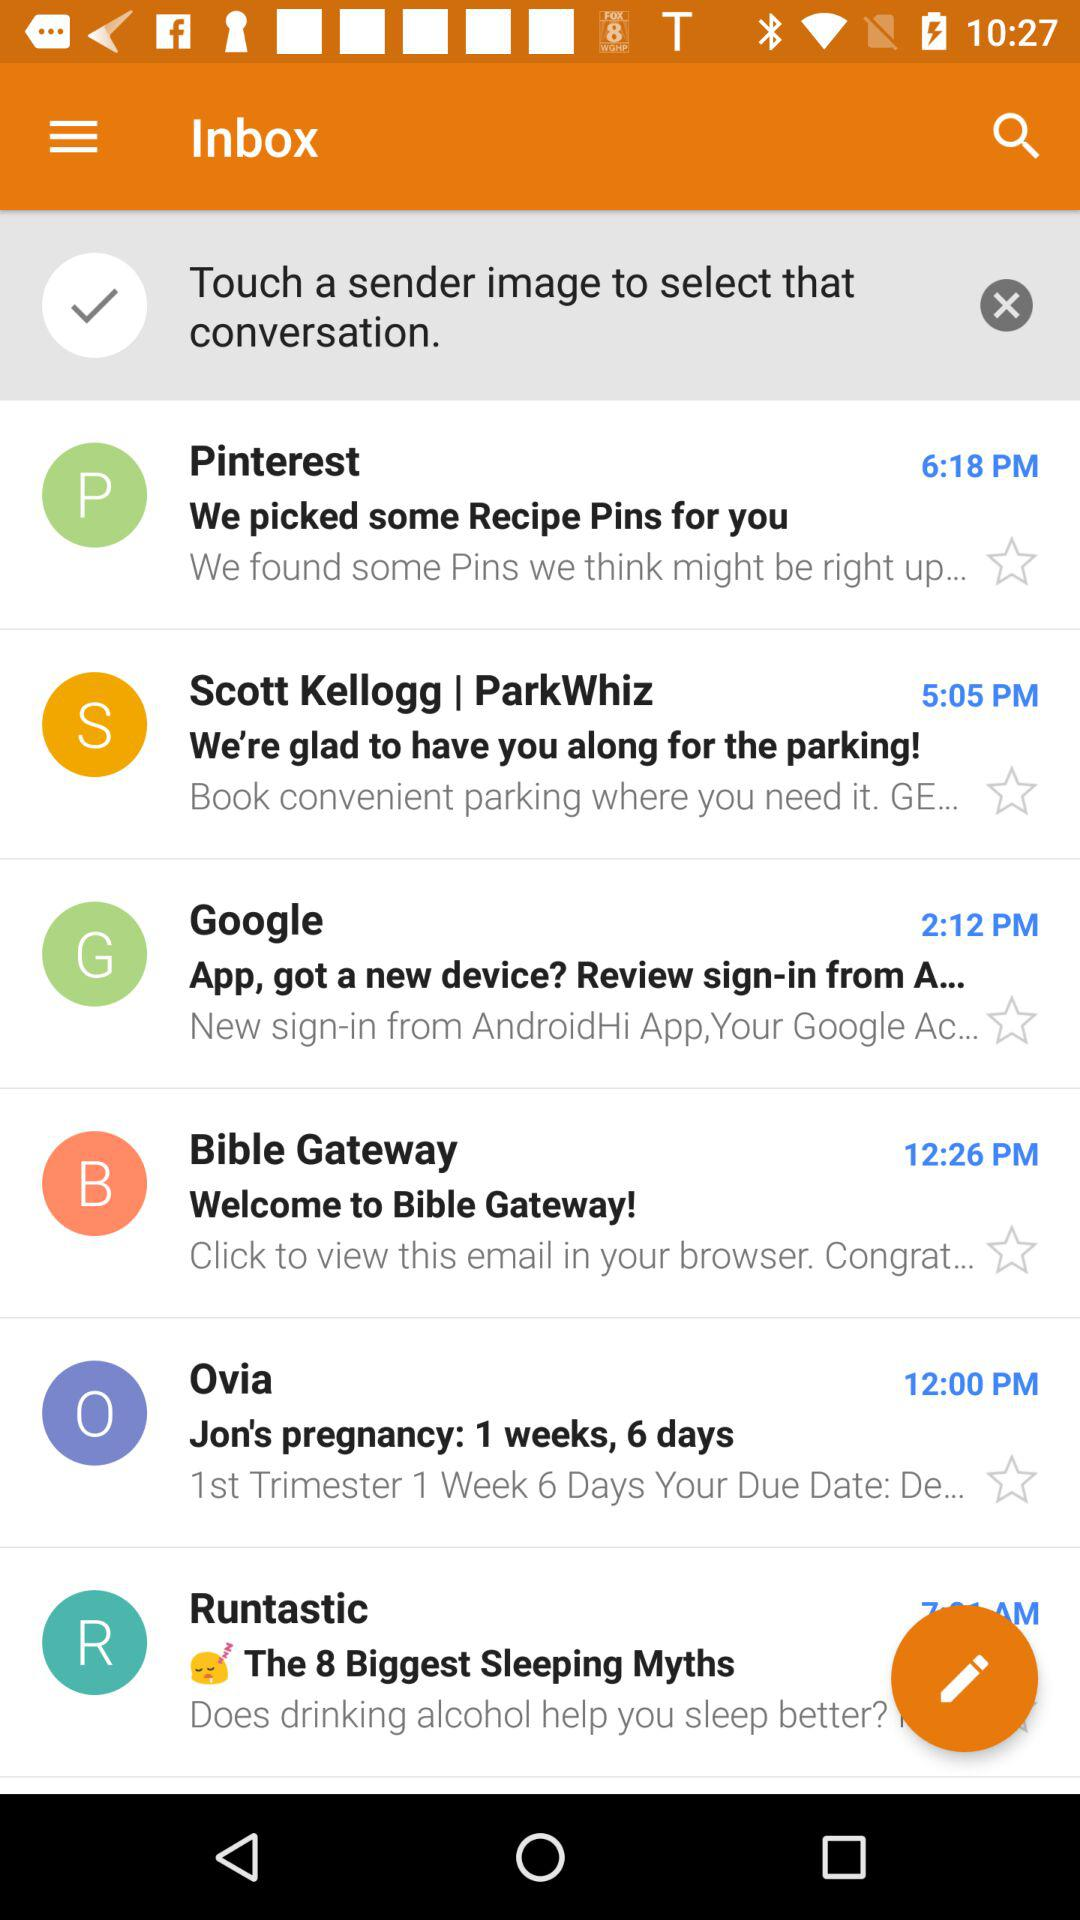From which user have we received the mail at 12:26 PM? You have received the mail from "Bible Gateway". 